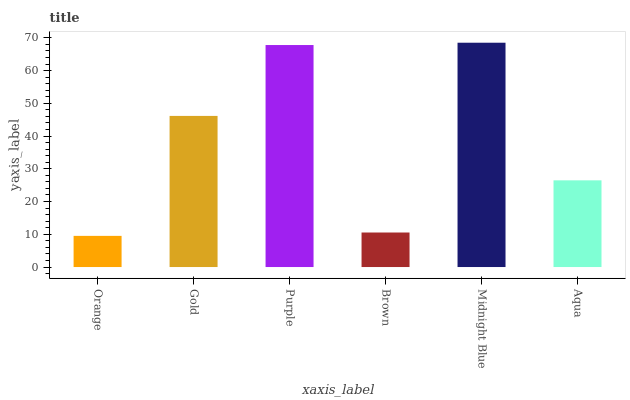Is Orange the minimum?
Answer yes or no. Yes. Is Midnight Blue the maximum?
Answer yes or no. Yes. Is Gold the minimum?
Answer yes or no. No. Is Gold the maximum?
Answer yes or no. No. Is Gold greater than Orange?
Answer yes or no. Yes. Is Orange less than Gold?
Answer yes or no. Yes. Is Orange greater than Gold?
Answer yes or no. No. Is Gold less than Orange?
Answer yes or no. No. Is Gold the high median?
Answer yes or no. Yes. Is Aqua the low median?
Answer yes or no. Yes. Is Orange the high median?
Answer yes or no. No. Is Brown the low median?
Answer yes or no. No. 